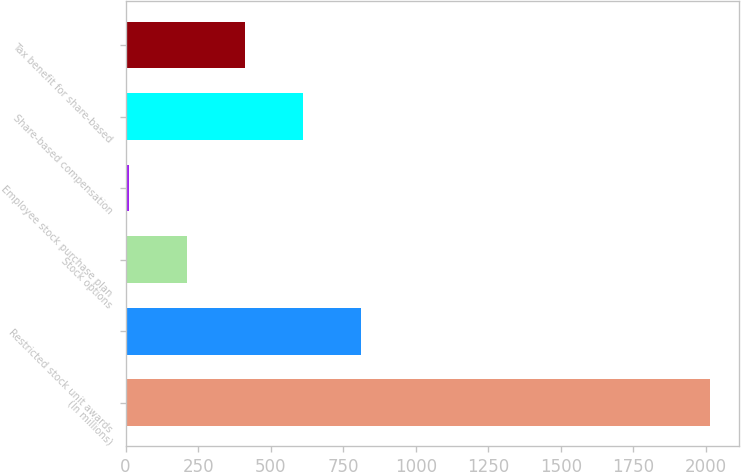Convert chart. <chart><loc_0><loc_0><loc_500><loc_500><bar_chart><fcel>(In millions)<fcel>Restricted stock unit awards<fcel>Stock options<fcel>Employee stock purchase plan<fcel>Share-based compensation<fcel>Tax benefit for share-based<nl><fcel>2013<fcel>811.8<fcel>211.2<fcel>11<fcel>611.6<fcel>411.4<nl></chart> 